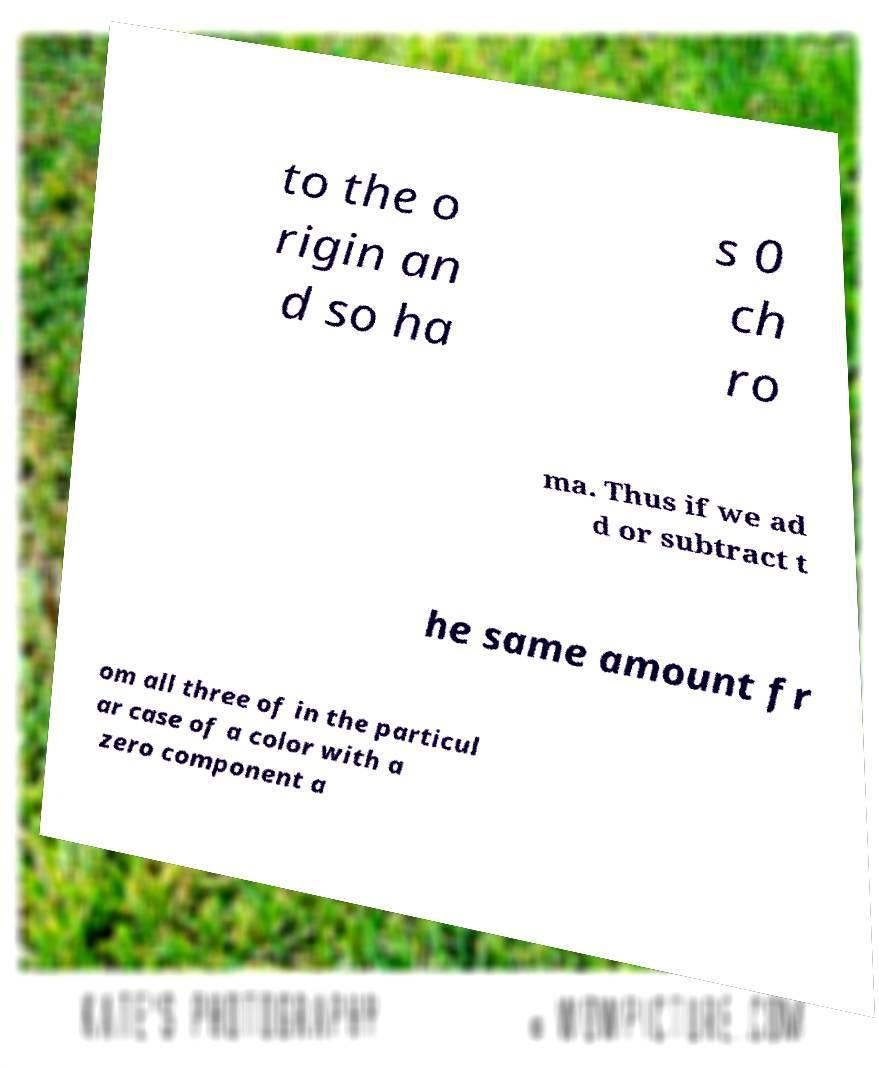Could you assist in decoding the text presented in this image and type it out clearly? to the o rigin an d so ha s 0 ch ro ma. Thus if we ad d or subtract t he same amount fr om all three of in the particul ar case of a color with a zero component a 